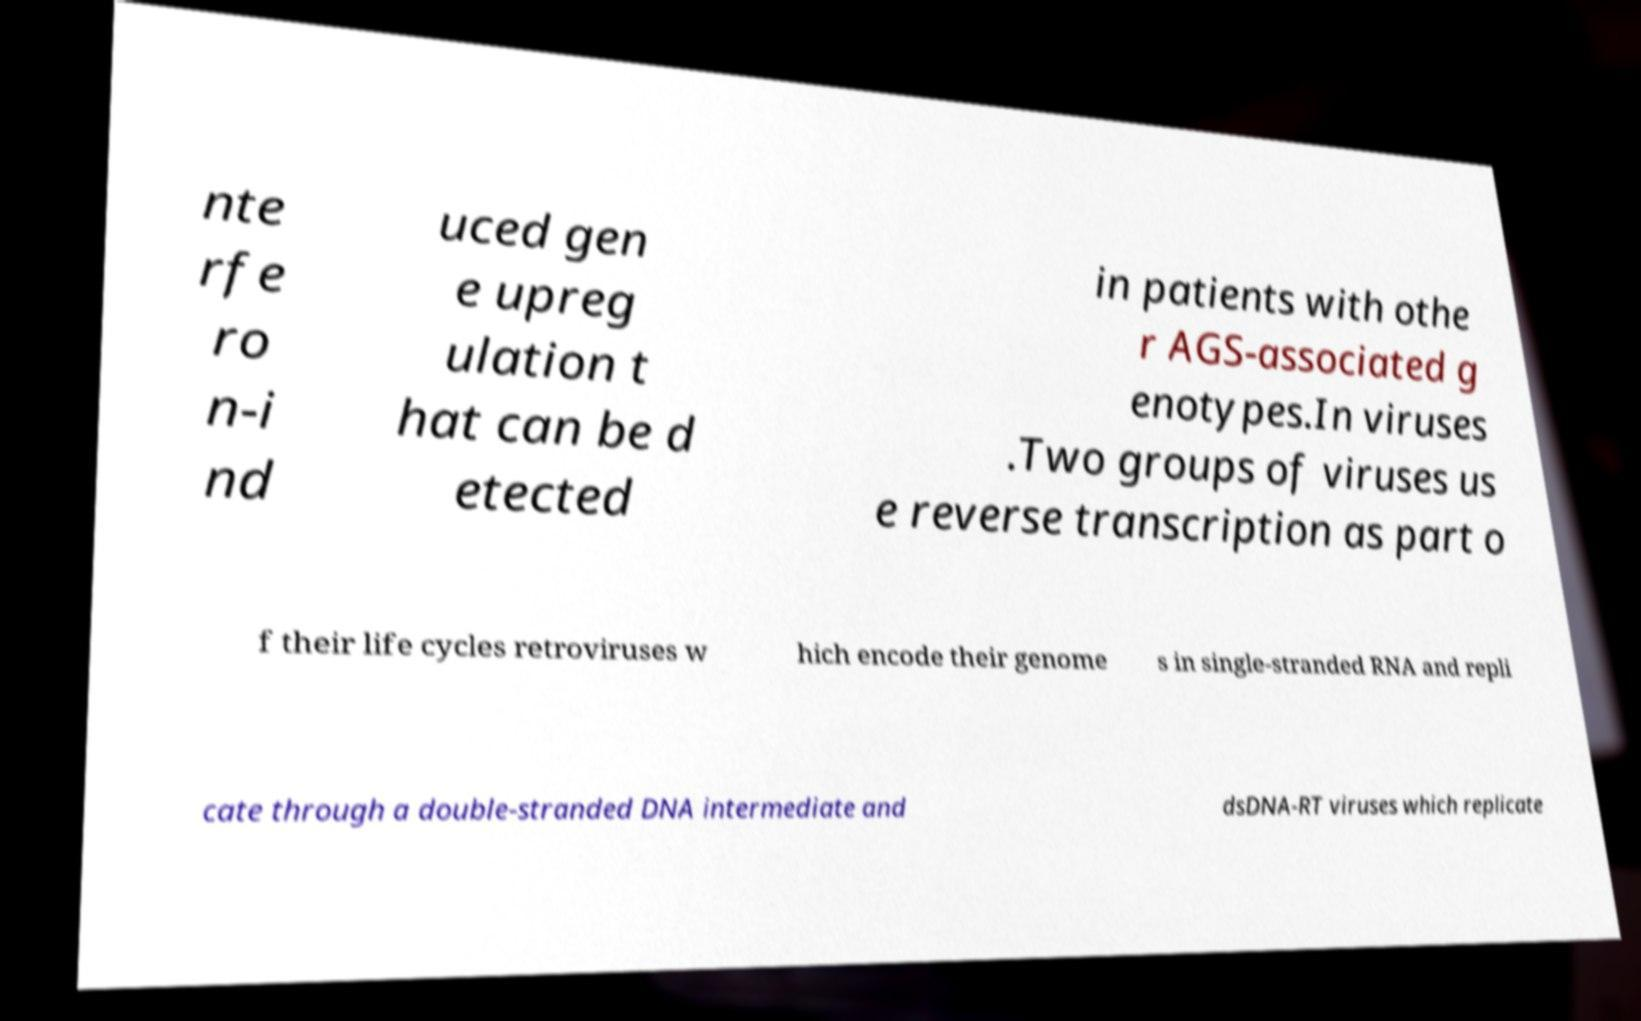Could you extract and type out the text from this image? nte rfe ro n-i nd uced gen e upreg ulation t hat can be d etected in patients with othe r AGS-associated g enotypes.In viruses .Two groups of viruses us e reverse transcription as part o f their life cycles retroviruses w hich encode their genome s in single-stranded RNA and repli cate through a double-stranded DNA intermediate and dsDNA-RT viruses which replicate 